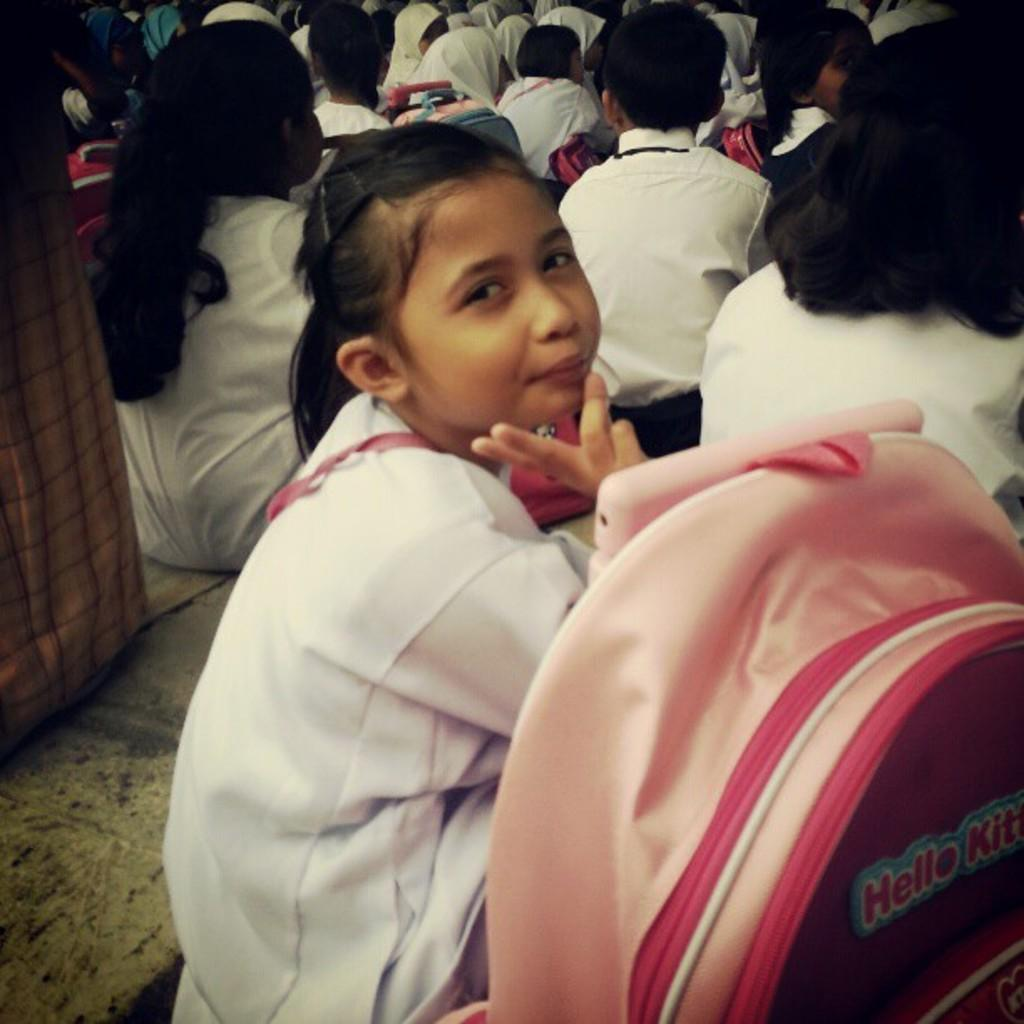Who or what can be seen in the image? There are people in the image. What are the people wearing? The people are wearing white dresses. What is a noticeable feature of the people's appearance? The people have black hair. What are the people holding in the image? The people are holding bags. What type of produce is being grown in the library in the image? There is no library or produce present in the image; it features people wearing white dresses and holding bags. 